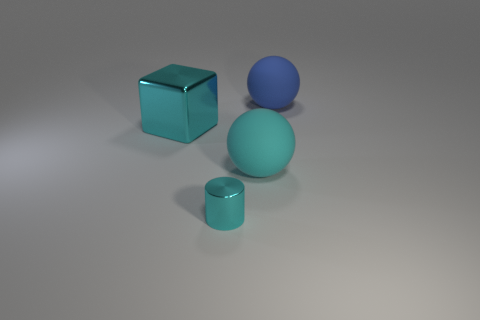There is another sphere that is the same size as the blue rubber sphere; what is it made of?
Give a very brief answer. Rubber. Is there another ball that has the same material as the large blue sphere?
Make the answer very short. Yes. What color is the thing that is both to the right of the tiny thing and behind the large cyan rubber sphere?
Give a very brief answer. Blue. What number of other objects are the same color as the small cylinder?
Ensure brevity in your answer.  2. What material is the large blue thing that is on the right side of the big cyan thing that is left of the rubber object in front of the big blue rubber ball?
Your answer should be compact. Rubber. How many cubes are either cyan rubber objects or tiny shiny things?
Your answer should be compact. 0. Is there any other thing that is the same size as the cube?
Your answer should be compact. Yes. What number of cyan shiny blocks are to the right of the sphere on the right side of the matte sphere left of the large blue object?
Your answer should be very brief. 0. Do the blue matte thing and the tiny object have the same shape?
Provide a succinct answer. No. Do the large cyan object in front of the large shiny block and the large object that is on the left side of the tiny cyan cylinder have the same material?
Your answer should be compact. No. 